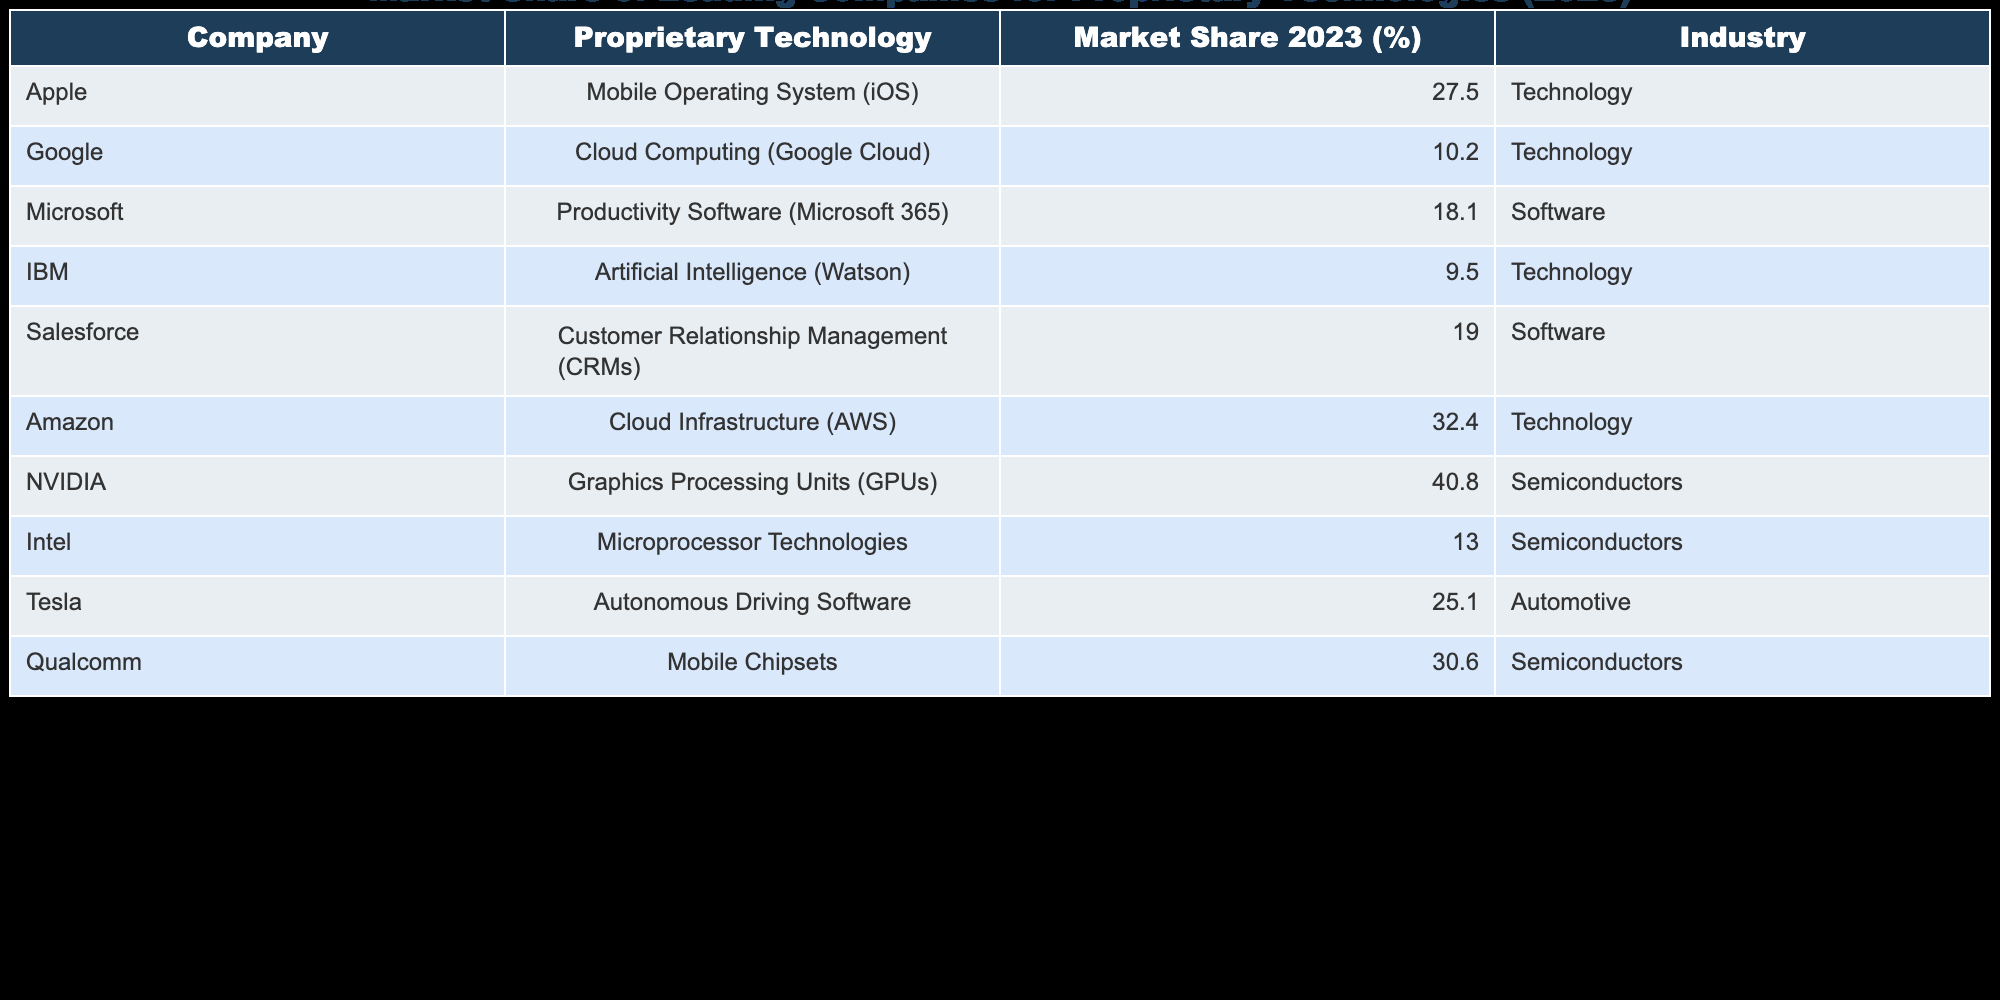What is the market share of Apple in 2023 for its proprietary technology? According to the table, Apple has a market share of 27.5% for its mobile operating system (iOS) in 2023.
Answer: 27.5% Which company has the highest market share in the semiconductor industry in 2023? The table shows that NVIDIA has the highest market share of 40.8% in the semiconductor industry in 2023.
Answer: NVIDIA What is the total market share percentage of all listed companies in the technology industry? To find the total market share in the technology industry, we add the market shares of Apple (27.5%), Google (10.2%), Amazon (32.4%), IBM (9.5%), and Tesla (25.1%). The sum is 27.5 + 10.2 + 32.4 + 9.5 + 25.1 = 104.7%.
Answer: 104.7% Is the market share of Google Cloud higher than that of IBM Watson? Google Cloud has a market share of 10.2% while IBM Watson has a market share of 9.5%. Since 10.2% is greater than 9.5%, the statement is true.
Answer: Yes What percentage of the combined market share do Microsoft and Salesforce hold in the software industry? Microsoft has a market share of 18.1% and Salesforce has 19.0%. Adding these together gives 18.1 + 19.0 = 37.1%. Therefore, the combined market share of Microsoft and Salesforce in the software industry is 37.1%.
Answer: 37.1% Which proprietary technology has the least market share, and what is its percentage? The smallest market share in the table belongs to IBM's artificial intelligence technology (Watson), with a market share of 9.5%.
Answer: IBM Watson, 9.5% Does Apple have a higher market share than Qualcomm in the semiconductor industry? Apple has a market share of 27.5% for its mobile operating system, while Qualcomm has a market share of 30.6% for mobile chipsets. Since 27.5% is less than 30.6%, the answer is no.
Answer: No Calculate the average market share of the companies in the automotive and semiconductor industries. The companies in the automotive industry (Tesla with 25.1%) and semiconductor industry (NVIDIA with 40.8%, Intel with 13.0%, Qualcomm with 30.6%) need to be averaged. The total market share is 25.1 + 40.8 + 13.0 + 30.6 = 109.5% and there are 4 companies, so the average is 109.5 / 4 = 27.375%.
Answer: 27.375% Which company has a market share of 32.4% and what technology does it represent? The table indicates that Amazon holds a market share of 32.4% for cloud infrastructure (AWS) in 2023.
Answer: Amazon, Cloud Infrastructure (AWS), 32.4% 